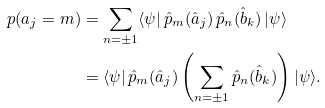Convert formula to latex. <formula><loc_0><loc_0><loc_500><loc_500>p ( a _ { j } = m ) & = \sum _ { n = \pm 1 } \langle \psi | \, \hat { p } _ { m } ( \hat { a } _ { j } ) \, \hat { p } _ { n } ( \hat { b } _ { k } ) \, | \psi \rangle \\ & = \langle \psi | \, \hat { p } _ { m } ( \hat { a } _ { j } ) \left ( \sum _ { n = \pm 1 } \hat { p } _ { n } ( \hat { b } _ { k } ) \right ) | \psi \rangle .</formula> 